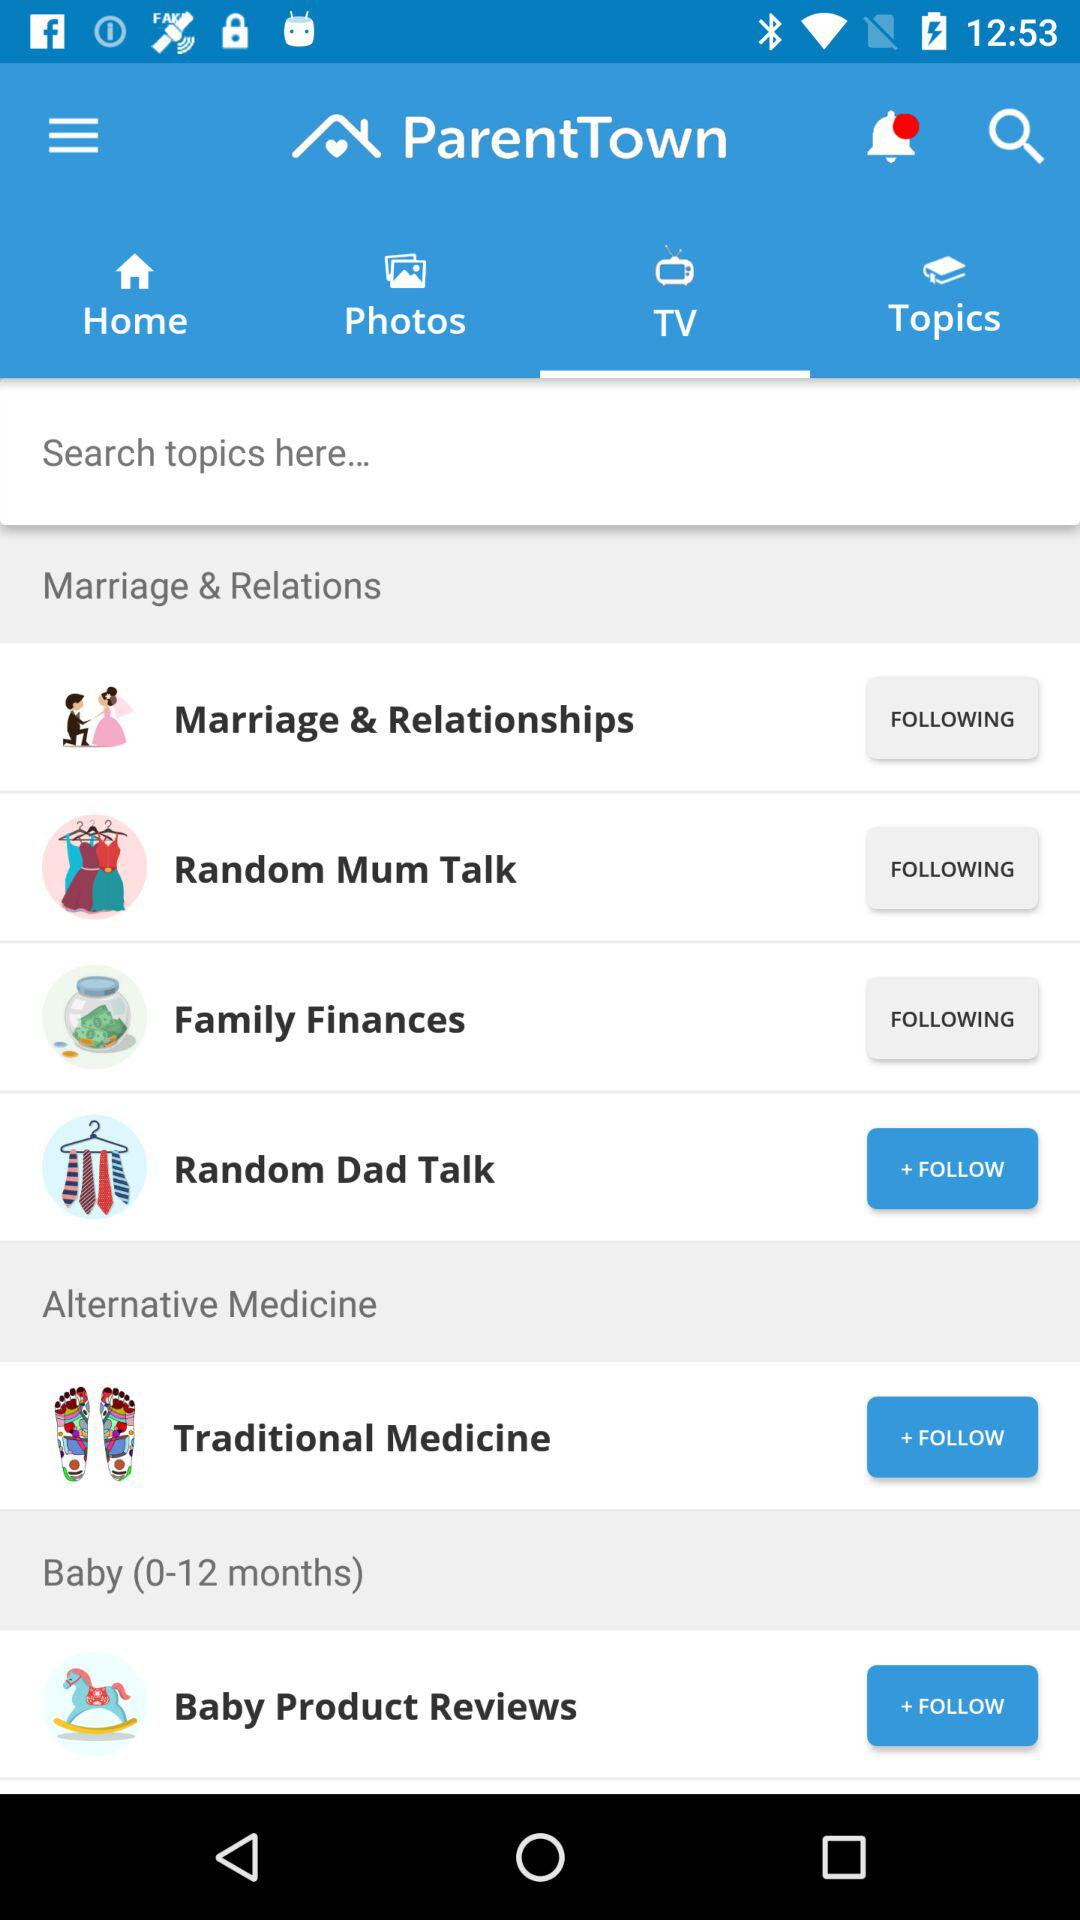Which option has been selected? The option "TV" has been selected. 